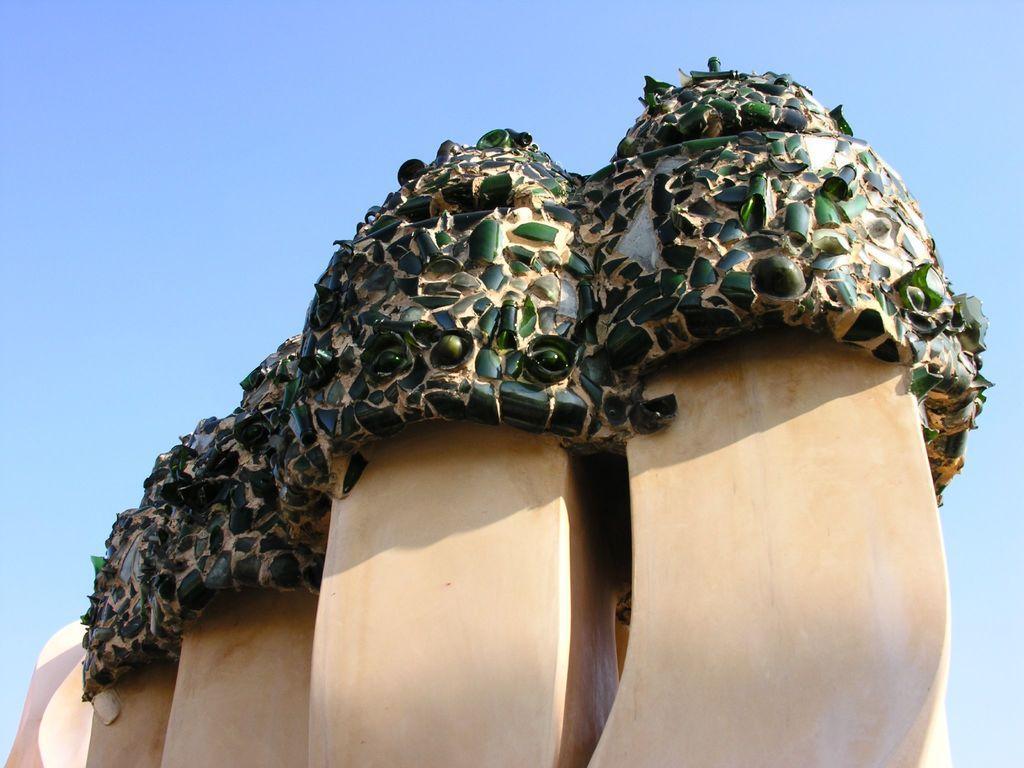In one or two sentences, can you explain what this image depicts? It is a structure and there are green color bottle pieces in it. 